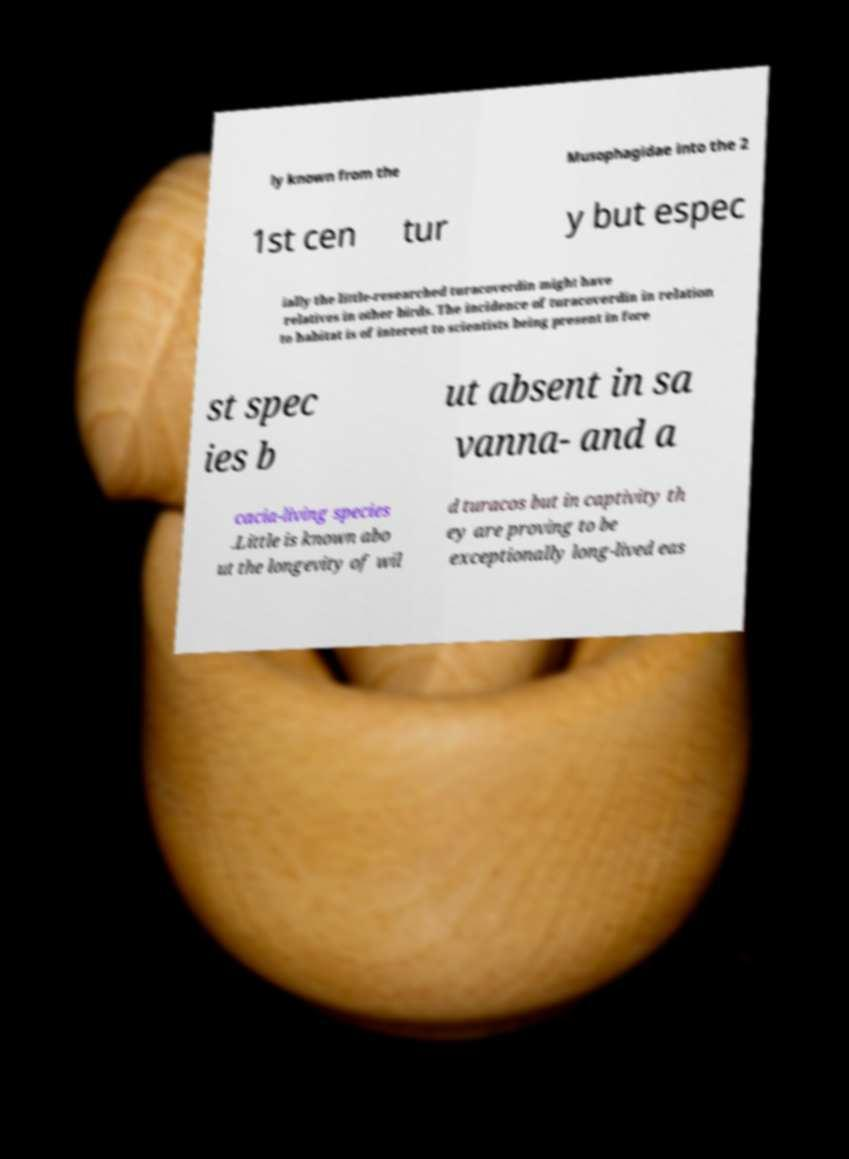Can you accurately transcribe the text from the provided image for me? ly known from the Musophagidae into the 2 1st cen tur y but espec ially the little-researched turacoverdin might have relatives in other birds. The incidence of turacoverdin in relation to habitat is of interest to scientists being present in fore st spec ies b ut absent in sa vanna- and a cacia-living species .Little is known abo ut the longevity of wil d turacos but in captivity th ey are proving to be exceptionally long-lived eas 